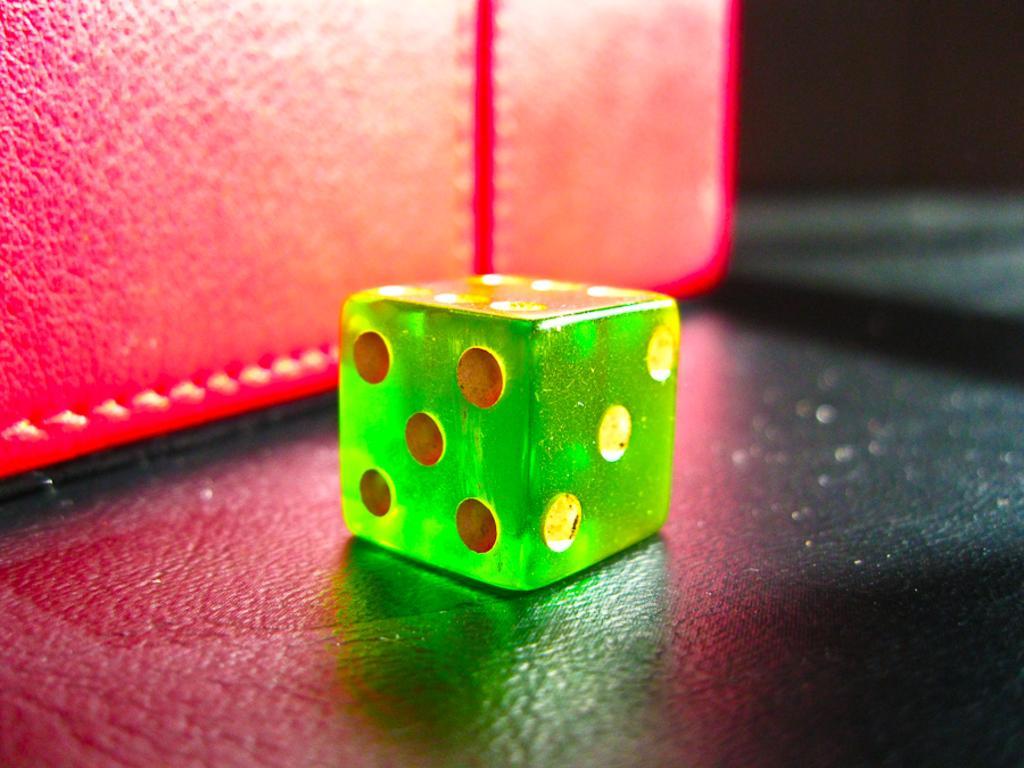In one or two sentences, can you explain what this image depicts? In this image there is a dice which is in green color. Beside the dice there is red color mat. 